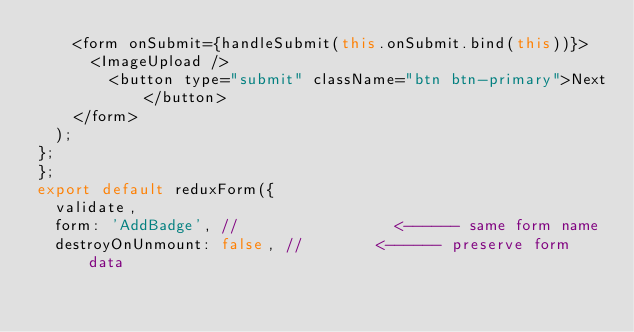<code> <loc_0><loc_0><loc_500><loc_500><_JavaScript_>    <form onSubmit={handleSubmit(this.onSubmit.bind(this))}>
      <ImageUpload />
        <button type="submit" className="btn btn-primary">Next</button>
    </form>
  );
};
};
export default reduxForm({
  validate,
  form: 'AddBadge', //                 <------ same form name
  destroyOnUnmount: false, //        <------ preserve form data</code> 